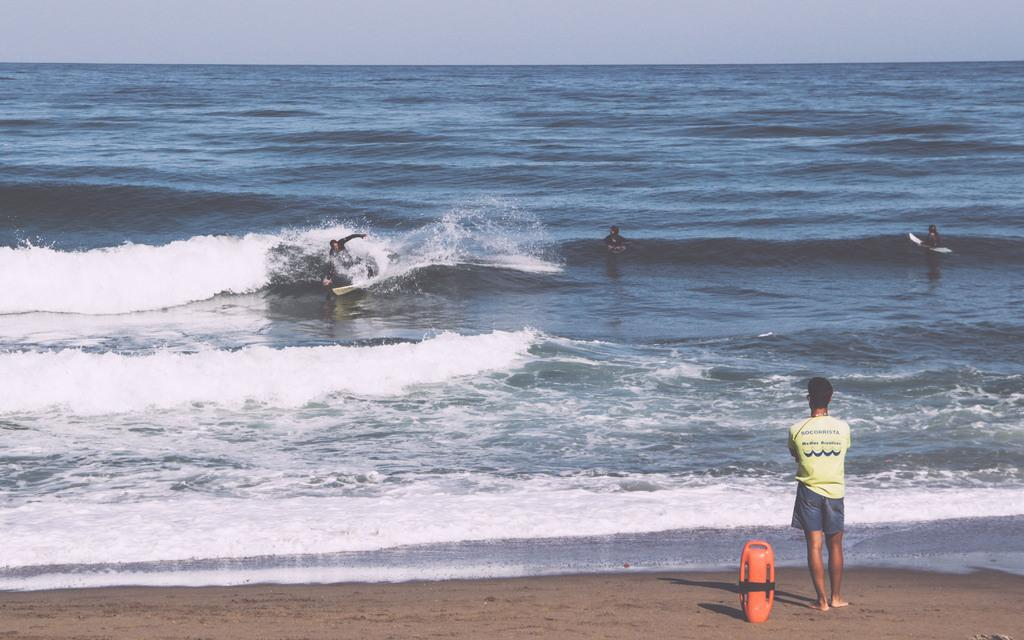What is the location of the person in the image? The person is standing at the beach. What are the people in the water doing? The people in the water are surfing. What type of plants can be seen growing in the water near the surfers? There are no plants visible in the water near the surfers in the image. 